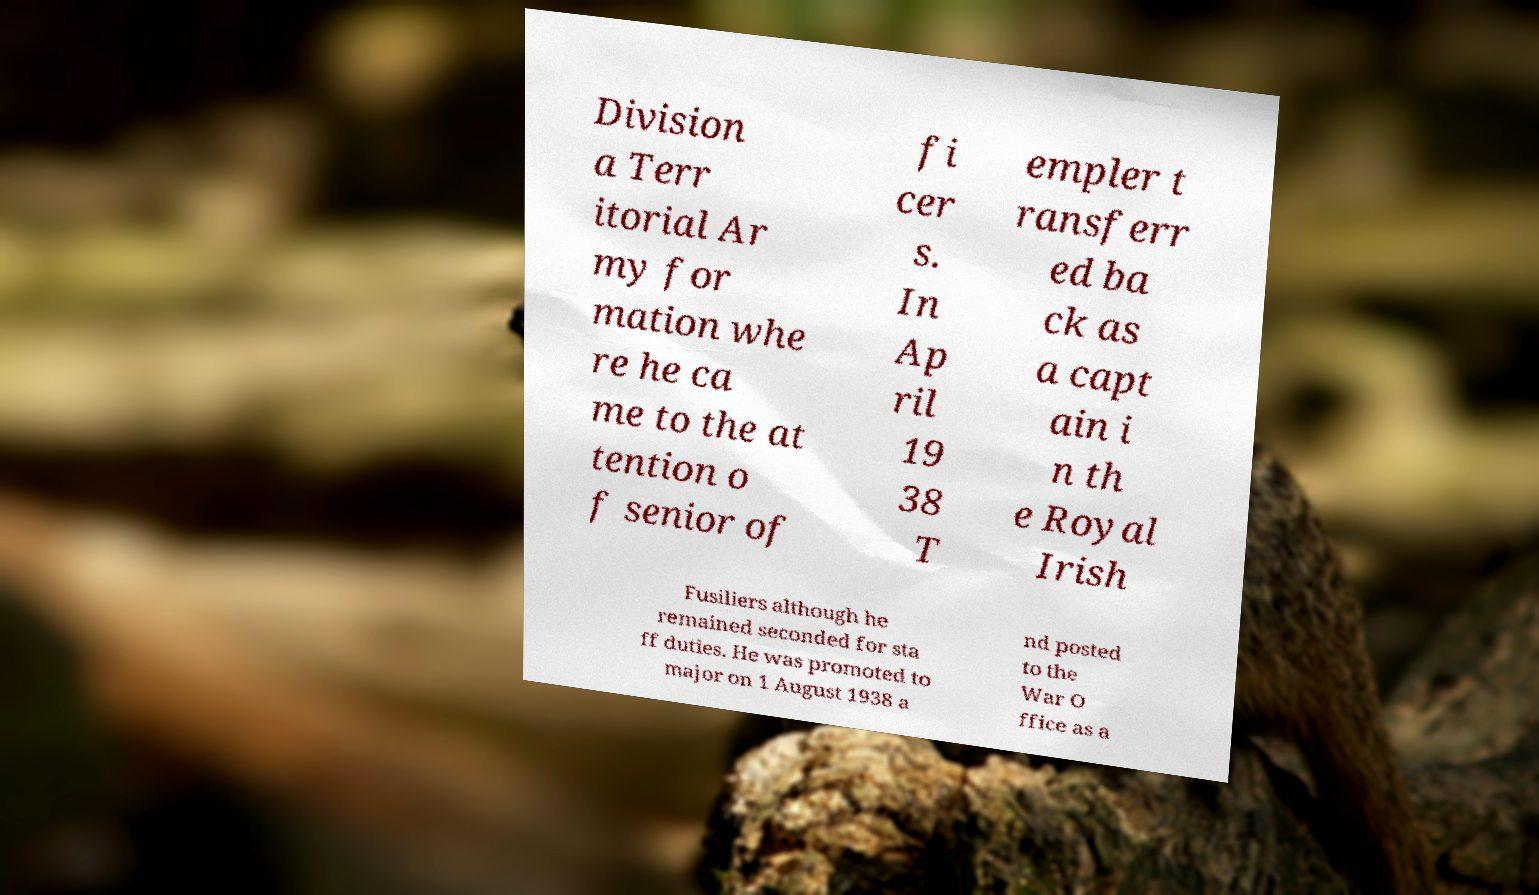Please identify and transcribe the text found in this image. Division a Terr itorial Ar my for mation whe re he ca me to the at tention o f senior of fi cer s. In Ap ril 19 38 T empler t ransferr ed ba ck as a capt ain i n th e Royal Irish Fusiliers although he remained seconded for sta ff duties. He was promoted to major on 1 August 1938 a nd posted to the War O ffice as a 